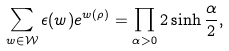<formula> <loc_0><loc_0><loc_500><loc_500>\sum _ { w \in \mathcal { W } } \epsilon ( w ) e ^ { w ( \rho ) } = \prod _ { \alpha > 0 } 2 \sinh { \frac { \alpha } { 2 } } ,</formula> 